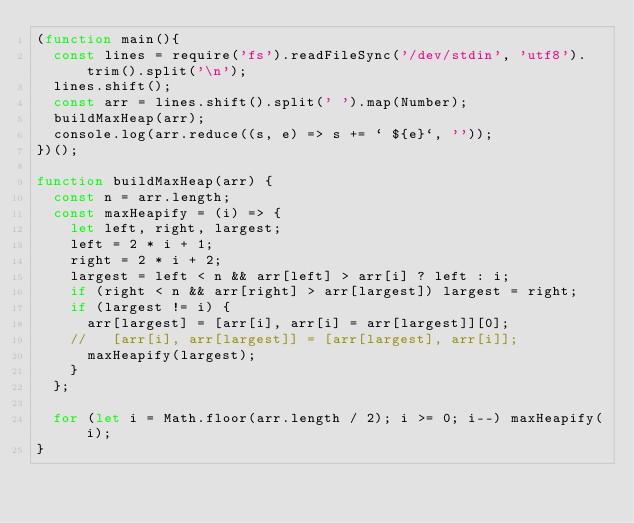Convert code to text. <code><loc_0><loc_0><loc_500><loc_500><_JavaScript_>(function main(){
  const lines = require('fs').readFileSync('/dev/stdin', 'utf8').trim().split('\n');
  lines.shift();
  const arr = lines.shift().split(' ').map(Number);
  buildMaxHeap(arr);
  console.log(arr.reduce((s, e) => s += ` ${e}`, ''));
})();

function buildMaxHeap(arr) {
  const n = arr.length;
  const maxHeapify = (i) => {
    let left, right, largest;
    left = 2 * i + 1;
    right = 2 * i + 2;
    largest = left < n && arr[left] > arr[i] ? left : i;
    if (right < n && arr[right] > arr[largest]) largest = right;
    if (largest != i) {
      arr[largest] = [arr[i], arr[i] = arr[largest]][0];
    //   [arr[i], arr[largest]] = [arr[largest], arr[i]];
      maxHeapify(largest);
    }
  };

  for (let i = Math.floor(arr.length / 2); i >= 0; i--) maxHeapify(i);
}

</code> 